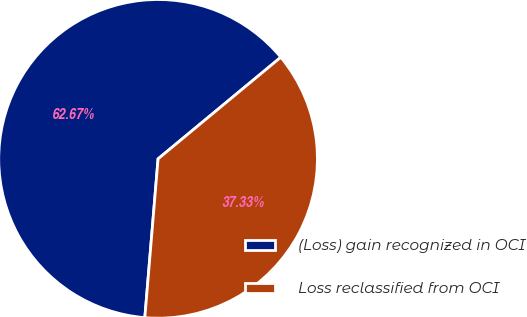Convert chart to OTSL. <chart><loc_0><loc_0><loc_500><loc_500><pie_chart><fcel>(Loss) gain recognized in OCI<fcel>Loss reclassified from OCI<nl><fcel>62.67%<fcel>37.33%<nl></chart> 